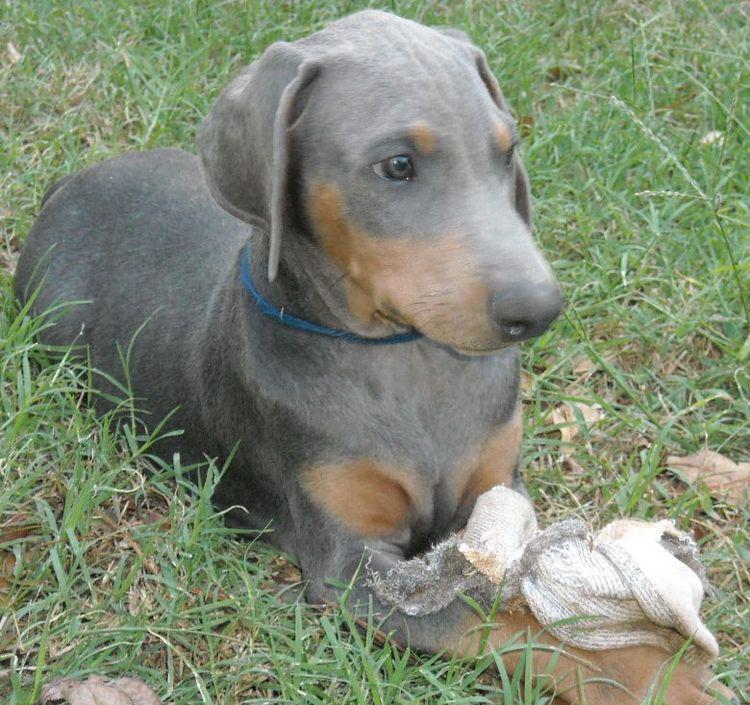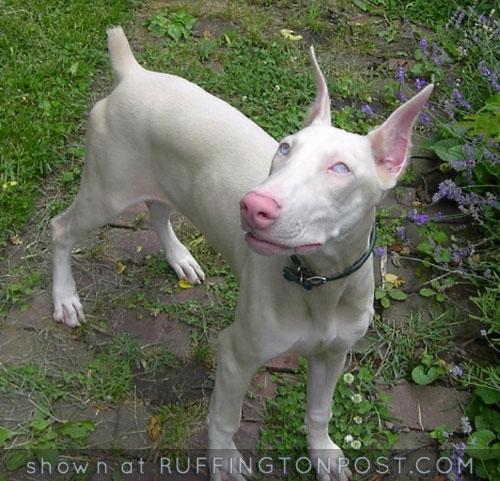The first image is the image on the left, the second image is the image on the right. Evaluate the accuracy of this statement regarding the images: "The right image features a pointy-eared black-and-tan doberman with docked tail standing with its body turned leftward.". Is it true? Answer yes or no. No. The first image is the image on the left, the second image is the image on the right. For the images shown, is this caption "There is only one dog with a collar" true? Answer yes or no. No. 